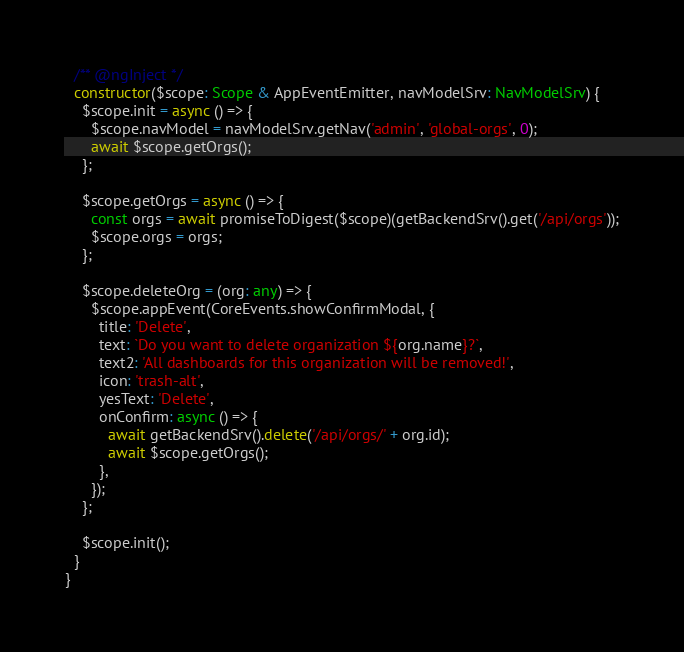Convert code to text. <code><loc_0><loc_0><loc_500><loc_500><_TypeScript_>  /** @ngInject */
  constructor($scope: Scope & AppEventEmitter, navModelSrv: NavModelSrv) {
    $scope.init = async () => {
      $scope.navModel = navModelSrv.getNav('admin', 'global-orgs', 0);
      await $scope.getOrgs();
    };

    $scope.getOrgs = async () => {
      const orgs = await promiseToDigest($scope)(getBackendSrv().get('/api/orgs'));
      $scope.orgs = orgs;
    };

    $scope.deleteOrg = (org: any) => {
      $scope.appEvent(CoreEvents.showConfirmModal, {
        title: 'Delete',
        text: `Do you want to delete organization ${org.name}?`,
        text2: 'All dashboards for this organization will be removed!',
        icon: 'trash-alt',
        yesText: 'Delete',
        onConfirm: async () => {
          await getBackendSrv().delete('/api/orgs/' + org.id);
          await $scope.getOrgs();
        },
      });
    };

    $scope.init();
  }
}
</code> 